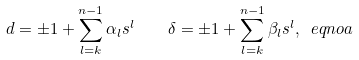Convert formula to latex. <formula><loc_0><loc_0><loc_500><loc_500>d = \pm 1 + \sum _ { l = k } ^ { n - 1 } \alpha _ { l } s ^ { l } \quad \delta = \pm 1 + \sum _ { l = k } ^ { n - 1 } \beta _ { l } s ^ { l } , \ e q n o a</formula> 